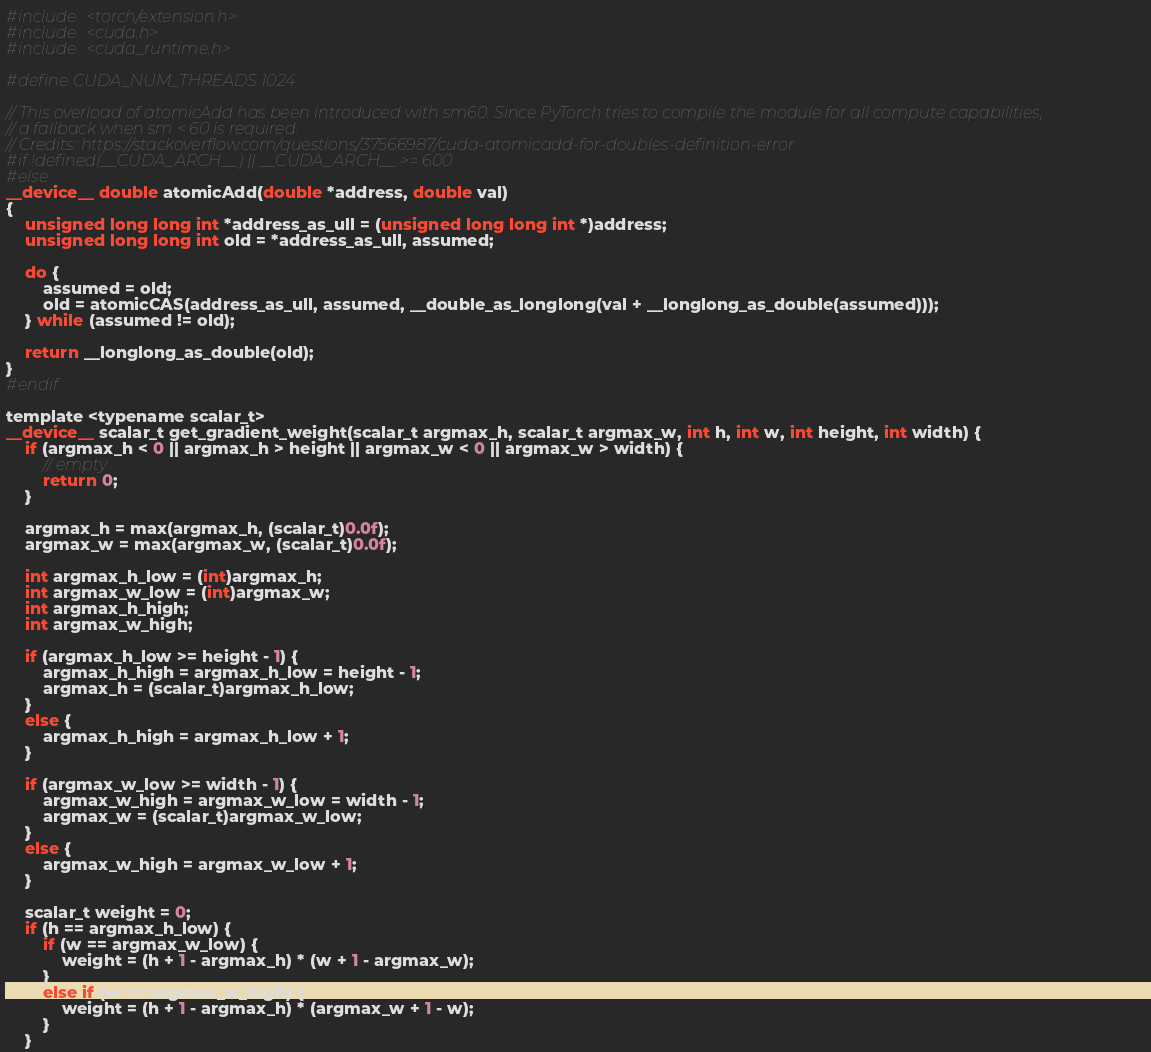<code> <loc_0><loc_0><loc_500><loc_500><_Cuda_>#include <torch/extension.h>
#include <cuda.h>
#include <cuda_runtime.h>

#define CUDA_NUM_THREADS 1024

// This overload of atomicAdd has been introduced with sm60. Since PyTorch tries to compile the module for all compute capabilities,
// a fallback when sm < 60 is required.
// Credits: https://stackoverflow.com/questions/37566987/cuda-atomicadd-for-doubles-definition-error
#if !defined(__CUDA_ARCH__) || __CUDA_ARCH__ >= 600
#else
__device__ double atomicAdd(double *address, double val)
{
    unsigned long long int *address_as_ull = (unsigned long long int *)address;
    unsigned long long int old = *address_as_ull, assumed;

    do {
        assumed = old;
        old = atomicCAS(address_as_ull, assumed, __double_as_longlong(val + __longlong_as_double(assumed)));
    } while (assumed != old);

    return __longlong_as_double(old);
}
#endif

template <typename scalar_t>
__device__ scalar_t get_gradient_weight(scalar_t argmax_h, scalar_t argmax_w, int h, int w, int height, int width) {
    if (argmax_h < 0 || argmax_h > height || argmax_w < 0 || argmax_w > width) {
        // empty
        return 0;
    }

    argmax_h = max(argmax_h, (scalar_t)0.0f);
    argmax_w = max(argmax_w, (scalar_t)0.0f);

    int argmax_h_low = (int)argmax_h;
    int argmax_w_low = (int)argmax_w;
    int argmax_h_high;
    int argmax_w_high;

    if (argmax_h_low >= height - 1) {
        argmax_h_high = argmax_h_low = height - 1;
        argmax_h = (scalar_t)argmax_h_low;
    }
    else {
        argmax_h_high = argmax_h_low + 1;
    }

    if (argmax_w_low >= width - 1) {
        argmax_w_high = argmax_w_low = width - 1;
        argmax_w = (scalar_t)argmax_w_low;
    }
    else {
        argmax_w_high = argmax_w_low + 1;
    }

    scalar_t weight = 0;
    if (h == argmax_h_low) {
        if (w == argmax_w_low) {
            weight = (h + 1 - argmax_h) * (w + 1 - argmax_w);
        }
        else if (w == argmax_w_high) {
            weight = (h + 1 - argmax_h) * (argmax_w + 1 - w);
        }
    }</code> 